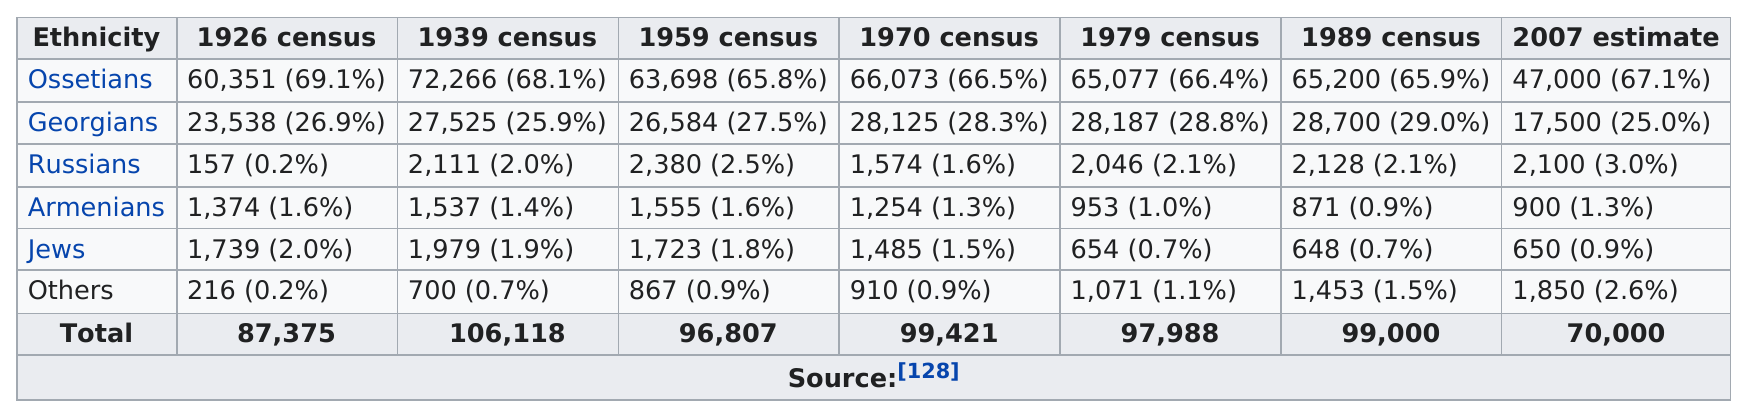Highlight a few significant elements in this photo. In 2007, there were a number of ethnicities with populations below 1,000. Specifically, there were two ethnicities that fit this criteria. There were four ethnicities with a population of at least 1,000 members in 1989. In 1926, the Ossetian population was the largest in terms of population size. There are 6 ethnicities. Ossetians are at the top of their ethnicity. 